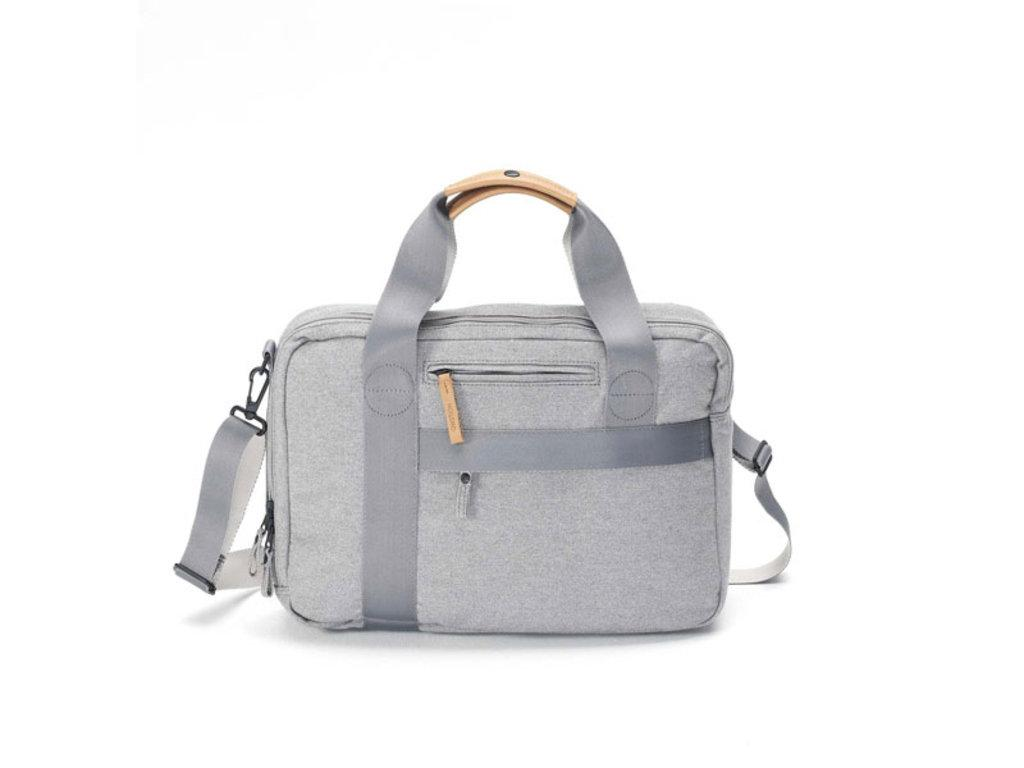What color is the handbag in the image? The handbag in the image is gray. What feature does the handbag have for securing its contents? The handbag has a zip. What type of locket can be seen hanging from the zip of the handbag in the image? There is no locket present on the zip of the handbag in the image. What color is the zebra standing next to the handbag in the image? There is no zebra present in the image. 